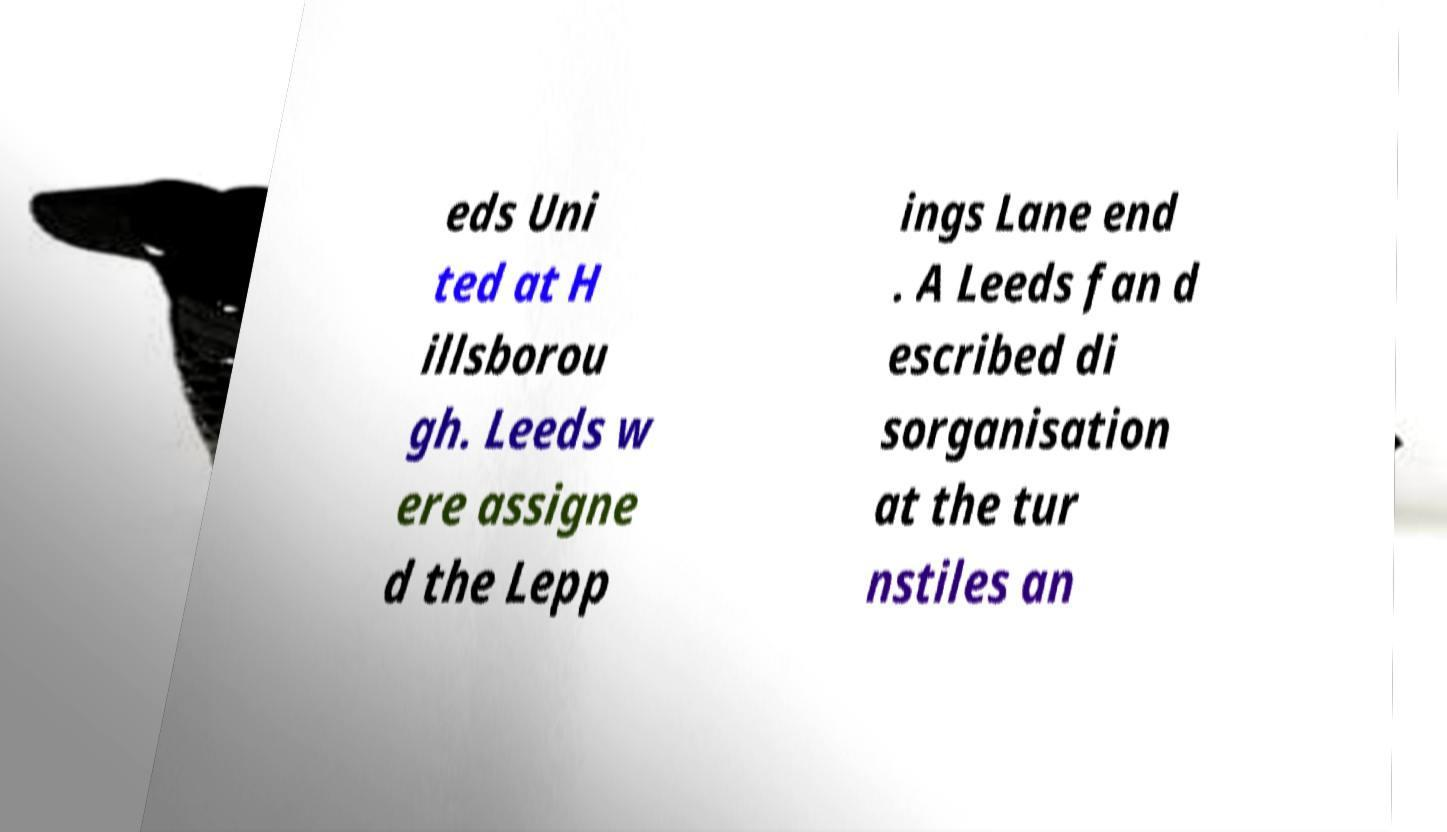There's text embedded in this image that I need extracted. Can you transcribe it verbatim? eds Uni ted at H illsborou gh. Leeds w ere assigne d the Lepp ings Lane end . A Leeds fan d escribed di sorganisation at the tur nstiles an 